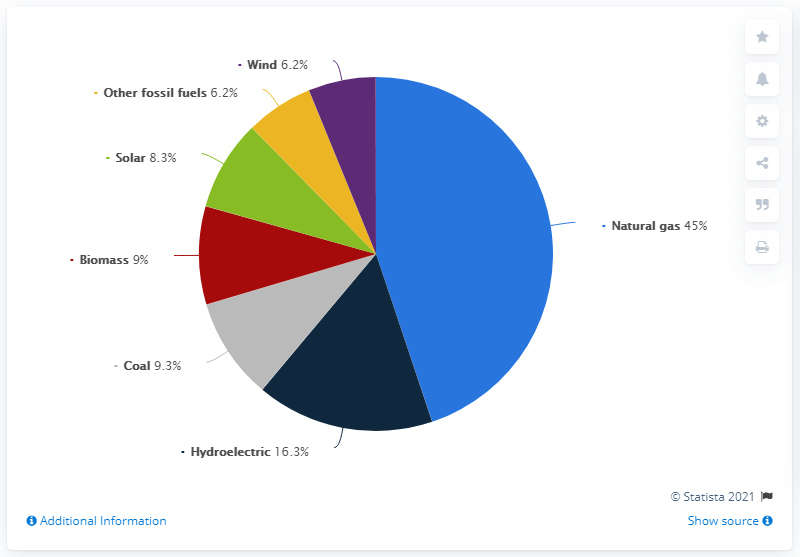Indicate a few pertinent items in this graphic. The difference between the highest and the second highest pies is 28.7.. The smallest pie is comprised of yellow and purple colors. 